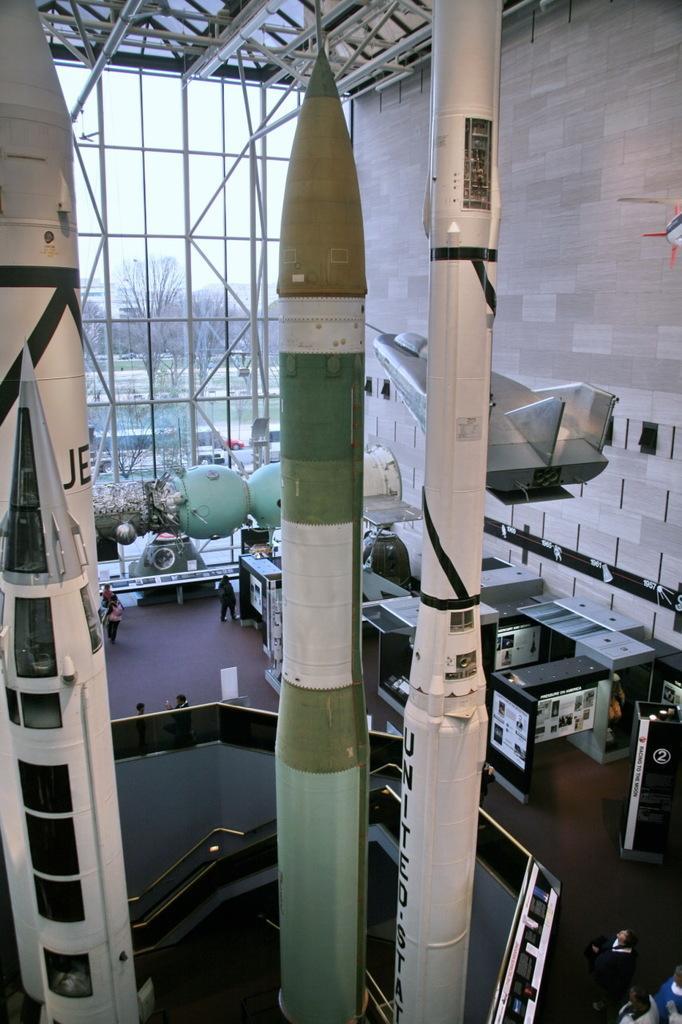Describe this image in one or two sentences. In this image I can see missiles, machines, tables, wall and a group of people. In the background I can see trees, water and the sky. This image is taken may be during a day. 